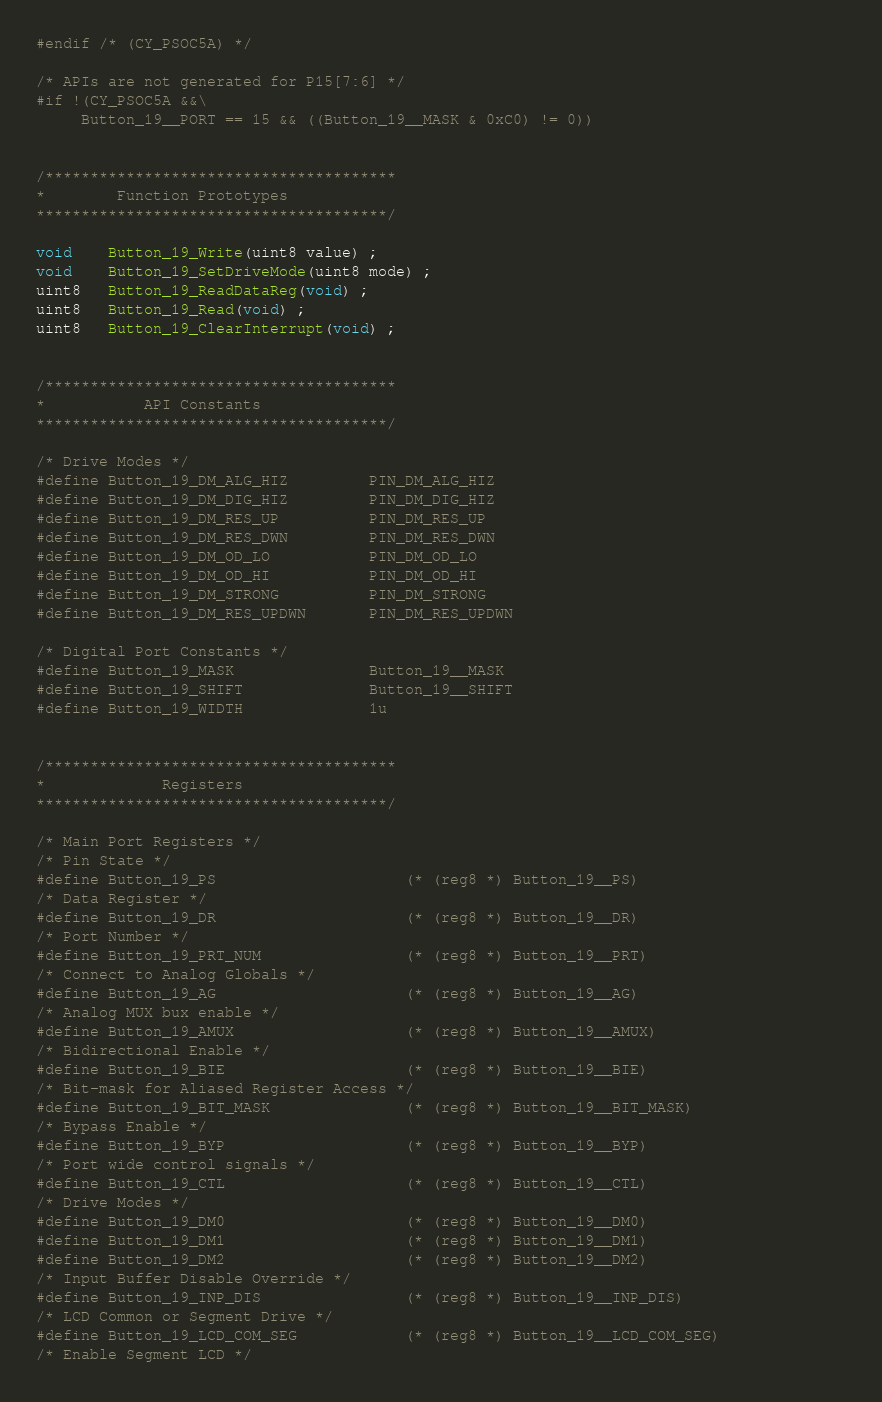<code> <loc_0><loc_0><loc_500><loc_500><_C_>#endif /* (CY_PSOC5A) */

/* APIs are not generated for P15[7:6] */
#if !(CY_PSOC5A &&\
	 Button_19__PORT == 15 && ((Button_19__MASK & 0xC0) != 0))


/***************************************
*        Function Prototypes             
***************************************/    

void    Button_19_Write(uint8 value) ;
void    Button_19_SetDriveMode(uint8 mode) ;
uint8   Button_19_ReadDataReg(void) ;
uint8   Button_19_Read(void) ;
uint8   Button_19_ClearInterrupt(void) ;


/***************************************
*           API Constants        
***************************************/

/* Drive Modes */
#define Button_19_DM_ALG_HIZ         PIN_DM_ALG_HIZ
#define Button_19_DM_DIG_HIZ         PIN_DM_DIG_HIZ
#define Button_19_DM_RES_UP          PIN_DM_RES_UP
#define Button_19_DM_RES_DWN         PIN_DM_RES_DWN
#define Button_19_DM_OD_LO           PIN_DM_OD_LO
#define Button_19_DM_OD_HI           PIN_DM_OD_HI
#define Button_19_DM_STRONG          PIN_DM_STRONG
#define Button_19_DM_RES_UPDWN       PIN_DM_RES_UPDWN

/* Digital Port Constants */
#define Button_19_MASK               Button_19__MASK
#define Button_19_SHIFT              Button_19__SHIFT
#define Button_19_WIDTH              1u


/***************************************
*             Registers        
***************************************/

/* Main Port Registers */
/* Pin State */
#define Button_19_PS                     (* (reg8 *) Button_19__PS)
/* Data Register */
#define Button_19_DR                     (* (reg8 *) Button_19__DR)
/* Port Number */
#define Button_19_PRT_NUM                (* (reg8 *) Button_19__PRT) 
/* Connect to Analog Globals */                                                  
#define Button_19_AG                     (* (reg8 *) Button_19__AG)                       
/* Analog MUX bux enable */
#define Button_19_AMUX                   (* (reg8 *) Button_19__AMUX) 
/* Bidirectional Enable */                                                        
#define Button_19_BIE                    (* (reg8 *) Button_19__BIE)
/* Bit-mask for Aliased Register Access */
#define Button_19_BIT_MASK               (* (reg8 *) Button_19__BIT_MASK)
/* Bypass Enable */
#define Button_19_BYP                    (* (reg8 *) Button_19__BYP)
/* Port wide control signals */                                                   
#define Button_19_CTL                    (* (reg8 *) Button_19__CTL)
/* Drive Modes */
#define Button_19_DM0                    (* (reg8 *) Button_19__DM0) 
#define Button_19_DM1                    (* (reg8 *) Button_19__DM1)
#define Button_19_DM2                    (* (reg8 *) Button_19__DM2) 
/* Input Buffer Disable Override */
#define Button_19_INP_DIS                (* (reg8 *) Button_19__INP_DIS)
/* LCD Common or Segment Drive */
#define Button_19_LCD_COM_SEG            (* (reg8 *) Button_19__LCD_COM_SEG)
/* Enable Segment LCD */</code> 